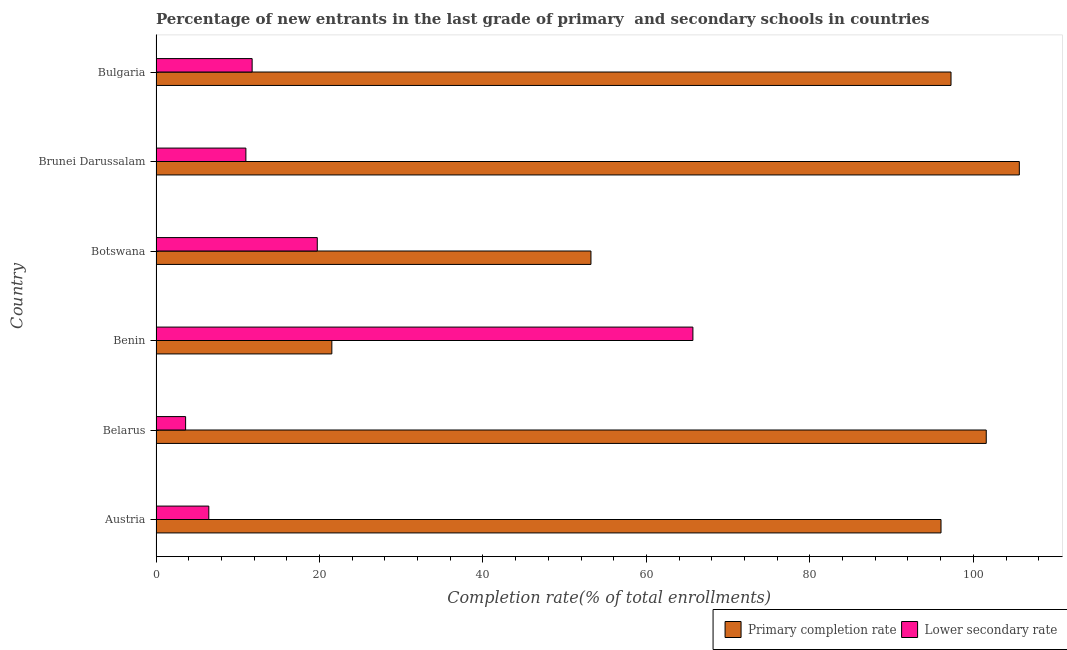Are the number of bars on each tick of the Y-axis equal?
Ensure brevity in your answer.  Yes. How many bars are there on the 2nd tick from the top?
Provide a succinct answer. 2. How many bars are there on the 2nd tick from the bottom?
Your answer should be very brief. 2. What is the completion rate in primary schools in Botswana?
Provide a succinct answer. 53.21. Across all countries, what is the maximum completion rate in secondary schools?
Ensure brevity in your answer.  65.69. Across all countries, what is the minimum completion rate in primary schools?
Your answer should be very brief. 21.51. In which country was the completion rate in secondary schools maximum?
Your response must be concise. Benin. In which country was the completion rate in secondary schools minimum?
Give a very brief answer. Belarus. What is the total completion rate in primary schools in the graph?
Ensure brevity in your answer.  475.22. What is the difference between the completion rate in primary schools in Austria and that in Belarus?
Keep it short and to the point. -5.54. What is the difference between the completion rate in secondary schools in Bulgaria and the completion rate in primary schools in Austria?
Make the answer very short. -84.28. What is the average completion rate in secondary schools per country?
Your answer should be compact. 19.71. What is the difference between the completion rate in secondary schools and completion rate in primary schools in Brunei Darussalam?
Your answer should be very brief. -94.63. What is the ratio of the completion rate in primary schools in Belarus to that in Benin?
Keep it short and to the point. 4.72. What is the difference between the highest and the second highest completion rate in secondary schools?
Your answer should be compact. 45.96. What is the difference between the highest and the lowest completion rate in primary schools?
Make the answer very short. 84.11. In how many countries, is the completion rate in primary schools greater than the average completion rate in primary schools taken over all countries?
Provide a succinct answer. 4. Is the sum of the completion rate in secondary schools in Belarus and Benin greater than the maximum completion rate in primary schools across all countries?
Offer a terse response. No. What does the 2nd bar from the top in Benin represents?
Make the answer very short. Primary completion rate. What does the 2nd bar from the bottom in Brunei Darussalam represents?
Your answer should be very brief. Lower secondary rate. How many bars are there?
Offer a very short reply. 12. Are all the bars in the graph horizontal?
Give a very brief answer. Yes. How many countries are there in the graph?
Give a very brief answer. 6. Does the graph contain grids?
Give a very brief answer. No. Where does the legend appear in the graph?
Make the answer very short. Bottom right. How many legend labels are there?
Make the answer very short. 2. How are the legend labels stacked?
Give a very brief answer. Horizontal. What is the title of the graph?
Give a very brief answer. Percentage of new entrants in the last grade of primary  and secondary schools in countries. What is the label or title of the X-axis?
Provide a short and direct response. Completion rate(% of total enrollments). What is the Completion rate(% of total enrollments) in Primary completion rate in Austria?
Offer a very short reply. 96.04. What is the Completion rate(% of total enrollments) of Lower secondary rate in Austria?
Provide a succinct answer. 6.46. What is the Completion rate(% of total enrollments) of Primary completion rate in Belarus?
Give a very brief answer. 101.58. What is the Completion rate(% of total enrollments) of Lower secondary rate in Belarus?
Offer a very short reply. 3.62. What is the Completion rate(% of total enrollments) of Primary completion rate in Benin?
Ensure brevity in your answer.  21.51. What is the Completion rate(% of total enrollments) of Lower secondary rate in Benin?
Give a very brief answer. 65.69. What is the Completion rate(% of total enrollments) in Primary completion rate in Botswana?
Provide a short and direct response. 53.21. What is the Completion rate(% of total enrollments) of Lower secondary rate in Botswana?
Your answer should be compact. 19.73. What is the Completion rate(% of total enrollments) in Primary completion rate in Brunei Darussalam?
Offer a terse response. 105.62. What is the Completion rate(% of total enrollments) in Lower secondary rate in Brunei Darussalam?
Your response must be concise. 10.99. What is the Completion rate(% of total enrollments) in Primary completion rate in Bulgaria?
Make the answer very short. 97.26. What is the Completion rate(% of total enrollments) in Lower secondary rate in Bulgaria?
Your answer should be compact. 11.76. Across all countries, what is the maximum Completion rate(% of total enrollments) of Primary completion rate?
Give a very brief answer. 105.62. Across all countries, what is the maximum Completion rate(% of total enrollments) of Lower secondary rate?
Your response must be concise. 65.69. Across all countries, what is the minimum Completion rate(% of total enrollments) in Primary completion rate?
Provide a short and direct response. 21.51. Across all countries, what is the minimum Completion rate(% of total enrollments) in Lower secondary rate?
Give a very brief answer. 3.62. What is the total Completion rate(% of total enrollments) in Primary completion rate in the graph?
Offer a terse response. 475.22. What is the total Completion rate(% of total enrollments) of Lower secondary rate in the graph?
Offer a very short reply. 118.25. What is the difference between the Completion rate(% of total enrollments) of Primary completion rate in Austria and that in Belarus?
Offer a very short reply. -5.54. What is the difference between the Completion rate(% of total enrollments) of Lower secondary rate in Austria and that in Belarus?
Ensure brevity in your answer.  2.84. What is the difference between the Completion rate(% of total enrollments) of Primary completion rate in Austria and that in Benin?
Provide a short and direct response. 74.53. What is the difference between the Completion rate(% of total enrollments) in Lower secondary rate in Austria and that in Benin?
Offer a terse response. -59.23. What is the difference between the Completion rate(% of total enrollments) in Primary completion rate in Austria and that in Botswana?
Give a very brief answer. 42.83. What is the difference between the Completion rate(% of total enrollments) of Lower secondary rate in Austria and that in Botswana?
Offer a very short reply. -13.27. What is the difference between the Completion rate(% of total enrollments) of Primary completion rate in Austria and that in Brunei Darussalam?
Keep it short and to the point. -9.58. What is the difference between the Completion rate(% of total enrollments) of Lower secondary rate in Austria and that in Brunei Darussalam?
Ensure brevity in your answer.  -4.54. What is the difference between the Completion rate(% of total enrollments) of Primary completion rate in Austria and that in Bulgaria?
Make the answer very short. -1.22. What is the difference between the Completion rate(% of total enrollments) of Lower secondary rate in Austria and that in Bulgaria?
Your answer should be very brief. -5.3. What is the difference between the Completion rate(% of total enrollments) of Primary completion rate in Belarus and that in Benin?
Offer a terse response. 80.06. What is the difference between the Completion rate(% of total enrollments) of Lower secondary rate in Belarus and that in Benin?
Provide a succinct answer. -62.07. What is the difference between the Completion rate(% of total enrollments) of Primary completion rate in Belarus and that in Botswana?
Your answer should be very brief. 48.36. What is the difference between the Completion rate(% of total enrollments) of Lower secondary rate in Belarus and that in Botswana?
Provide a succinct answer. -16.11. What is the difference between the Completion rate(% of total enrollments) of Primary completion rate in Belarus and that in Brunei Darussalam?
Make the answer very short. -4.05. What is the difference between the Completion rate(% of total enrollments) of Lower secondary rate in Belarus and that in Brunei Darussalam?
Provide a succinct answer. -7.37. What is the difference between the Completion rate(% of total enrollments) in Primary completion rate in Belarus and that in Bulgaria?
Ensure brevity in your answer.  4.31. What is the difference between the Completion rate(% of total enrollments) in Lower secondary rate in Belarus and that in Bulgaria?
Offer a terse response. -8.14. What is the difference between the Completion rate(% of total enrollments) in Primary completion rate in Benin and that in Botswana?
Give a very brief answer. -31.7. What is the difference between the Completion rate(% of total enrollments) in Lower secondary rate in Benin and that in Botswana?
Your response must be concise. 45.96. What is the difference between the Completion rate(% of total enrollments) of Primary completion rate in Benin and that in Brunei Darussalam?
Your response must be concise. -84.11. What is the difference between the Completion rate(% of total enrollments) in Lower secondary rate in Benin and that in Brunei Darussalam?
Give a very brief answer. 54.69. What is the difference between the Completion rate(% of total enrollments) of Primary completion rate in Benin and that in Bulgaria?
Offer a very short reply. -75.75. What is the difference between the Completion rate(% of total enrollments) of Lower secondary rate in Benin and that in Bulgaria?
Offer a very short reply. 53.93. What is the difference between the Completion rate(% of total enrollments) in Primary completion rate in Botswana and that in Brunei Darussalam?
Provide a succinct answer. -52.41. What is the difference between the Completion rate(% of total enrollments) in Lower secondary rate in Botswana and that in Brunei Darussalam?
Offer a terse response. 8.74. What is the difference between the Completion rate(% of total enrollments) in Primary completion rate in Botswana and that in Bulgaria?
Offer a terse response. -44.05. What is the difference between the Completion rate(% of total enrollments) of Lower secondary rate in Botswana and that in Bulgaria?
Provide a succinct answer. 7.97. What is the difference between the Completion rate(% of total enrollments) in Primary completion rate in Brunei Darussalam and that in Bulgaria?
Make the answer very short. 8.36. What is the difference between the Completion rate(% of total enrollments) of Lower secondary rate in Brunei Darussalam and that in Bulgaria?
Give a very brief answer. -0.77. What is the difference between the Completion rate(% of total enrollments) of Primary completion rate in Austria and the Completion rate(% of total enrollments) of Lower secondary rate in Belarus?
Provide a short and direct response. 92.42. What is the difference between the Completion rate(% of total enrollments) of Primary completion rate in Austria and the Completion rate(% of total enrollments) of Lower secondary rate in Benin?
Provide a short and direct response. 30.35. What is the difference between the Completion rate(% of total enrollments) in Primary completion rate in Austria and the Completion rate(% of total enrollments) in Lower secondary rate in Botswana?
Ensure brevity in your answer.  76.31. What is the difference between the Completion rate(% of total enrollments) of Primary completion rate in Austria and the Completion rate(% of total enrollments) of Lower secondary rate in Brunei Darussalam?
Ensure brevity in your answer.  85.05. What is the difference between the Completion rate(% of total enrollments) of Primary completion rate in Austria and the Completion rate(% of total enrollments) of Lower secondary rate in Bulgaria?
Your response must be concise. 84.28. What is the difference between the Completion rate(% of total enrollments) of Primary completion rate in Belarus and the Completion rate(% of total enrollments) of Lower secondary rate in Benin?
Provide a short and direct response. 35.89. What is the difference between the Completion rate(% of total enrollments) of Primary completion rate in Belarus and the Completion rate(% of total enrollments) of Lower secondary rate in Botswana?
Your answer should be compact. 81.85. What is the difference between the Completion rate(% of total enrollments) in Primary completion rate in Belarus and the Completion rate(% of total enrollments) in Lower secondary rate in Brunei Darussalam?
Provide a short and direct response. 90.58. What is the difference between the Completion rate(% of total enrollments) in Primary completion rate in Belarus and the Completion rate(% of total enrollments) in Lower secondary rate in Bulgaria?
Ensure brevity in your answer.  89.82. What is the difference between the Completion rate(% of total enrollments) in Primary completion rate in Benin and the Completion rate(% of total enrollments) in Lower secondary rate in Botswana?
Provide a short and direct response. 1.78. What is the difference between the Completion rate(% of total enrollments) in Primary completion rate in Benin and the Completion rate(% of total enrollments) in Lower secondary rate in Brunei Darussalam?
Offer a terse response. 10.52. What is the difference between the Completion rate(% of total enrollments) in Primary completion rate in Benin and the Completion rate(% of total enrollments) in Lower secondary rate in Bulgaria?
Ensure brevity in your answer.  9.75. What is the difference between the Completion rate(% of total enrollments) in Primary completion rate in Botswana and the Completion rate(% of total enrollments) in Lower secondary rate in Brunei Darussalam?
Provide a succinct answer. 42.22. What is the difference between the Completion rate(% of total enrollments) of Primary completion rate in Botswana and the Completion rate(% of total enrollments) of Lower secondary rate in Bulgaria?
Your answer should be very brief. 41.45. What is the difference between the Completion rate(% of total enrollments) in Primary completion rate in Brunei Darussalam and the Completion rate(% of total enrollments) in Lower secondary rate in Bulgaria?
Give a very brief answer. 93.86. What is the average Completion rate(% of total enrollments) of Primary completion rate per country?
Provide a short and direct response. 79.2. What is the average Completion rate(% of total enrollments) of Lower secondary rate per country?
Your response must be concise. 19.71. What is the difference between the Completion rate(% of total enrollments) of Primary completion rate and Completion rate(% of total enrollments) of Lower secondary rate in Austria?
Keep it short and to the point. 89.58. What is the difference between the Completion rate(% of total enrollments) in Primary completion rate and Completion rate(% of total enrollments) in Lower secondary rate in Belarus?
Give a very brief answer. 97.95. What is the difference between the Completion rate(% of total enrollments) of Primary completion rate and Completion rate(% of total enrollments) of Lower secondary rate in Benin?
Offer a very short reply. -44.17. What is the difference between the Completion rate(% of total enrollments) of Primary completion rate and Completion rate(% of total enrollments) of Lower secondary rate in Botswana?
Make the answer very short. 33.48. What is the difference between the Completion rate(% of total enrollments) of Primary completion rate and Completion rate(% of total enrollments) of Lower secondary rate in Brunei Darussalam?
Offer a very short reply. 94.63. What is the difference between the Completion rate(% of total enrollments) of Primary completion rate and Completion rate(% of total enrollments) of Lower secondary rate in Bulgaria?
Keep it short and to the point. 85.5. What is the ratio of the Completion rate(% of total enrollments) in Primary completion rate in Austria to that in Belarus?
Give a very brief answer. 0.95. What is the ratio of the Completion rate(% of total enrollments) in Lower secondary rate in Austria to that in Belarus?
Your answer should be compact. 1.78. What is the ratio of the Completion rate(% of total enrollments) in Primary completion rate in Austria to that in Benin?
Ensure brevity in your answer.  4.46. What is the ratio of the Completion rate(% of total enrollments) in Lower secondary rate in Austria to that in Benin?
Offer a terse response. 0.1. What is the ratio of the Completion rate(% of total enrollments) of Primary completion rate in Austria to that in Botswana?
Provide a short and direct response. 1.8. What is the ratio of the Completion rate(% of total enrollments) in Lower secondary rate in Austria to that in Botswana?
Your answer should be compact. 0.33. What is the ratio of the Completion rate(% of total enrollments) in Primary completion rate in Austria to that in Brunei Darussalam?
Your answer should be very brief. 0.91. What is the ratio of the Completion rate(% of total enrollments) of Lower secondary rate in Austria to that in Brunei Darussalam?
Your answer should be very brief. 0.59. What is the ratio of the Completion rate(% of total enrollments) in Primary completion rate in Austria to that in Bulgaria?
Give a very brief answer. 0.99. What is the ratio of the Completion rate(% of total enrollments) of Lower secondary rate in Austria to that in Bulgaria?
Your answer should be compact. 0.55. What is the ratio of the Completion rate(% of total enrollments) in Primary completion rate in Belarus to that in Benin?
Offer a terse response. 4.72. What is the ratio of the Completion rate(% of total enrollments) in Lower secondary rate in Belarus to that in Benin?
Your answer should be very brief. 0.06. What is the ratio of the Completion rate(% of total enrollments) of Primary completion rate in Belarus to that in Botswana?
Your answer should be compact. 1.91. What is the ratio of the Completion rate(% of total enrollments) of Lower secondary rate in Belarus to that in Botswana?
Your answer should be compact. 0.18. What is the ratio of the Completion rate(% of total enrollments) of Primary completion rate in Belarus to that in Brunei Darussalam?
Your answer should be very brief. 0.96. What is the ratio of the Completion rate(% of total enrollments) in Lower secondary rate in Belarus to that in Brunei Darussalam?
Your response must be concise. 0.33. What is the ratio of the Completion rate(% of total enrollments) in Primary completion rate in Belarus to that in Bulgaria?
Provide a succinct answer. 1.04. What is the ratio of the Completion rate(% of total enrollments) in Lower secondary rate in Belarus to that in Bulgaria?
Keep it short and to the point. 0.31. What is the ratio of the Completion rate(% of total enrollments) of Primary completion rate in Benin to that in Botswana?
Ensure brevity in your answer.  0.4. What is the ratio of the Completion rate(% of total enrollments) in Lower secondary rate in Benin to that in Botswana?
Offer a very short reply. 3.33. What is the ratio of the Completion rate(% of total enrollments) of Primary completion rate in Benin to that in Brunei Darussalam?
Ensure brevity in your answer.  0.2. What is the ratio of the Completion rate(% of total enrollments) in Lower secondary rate in Benin to that in Brunei Darussalam?
Offer a terse response. 5.97. What is the ratio of the Completion rate(% of total enrollments) of Primary completion rate in Benin to that in Bulgaria?
Provide a short and direct response. 0.22. What is the ratio of the Completion rate(% of total enrollments) of Lower secondary rate in Benin to that in Bulgaria?
Make the answer very short. 5.59. What is the ratio of the Completion rate(% of total enrollments) in Primary completion rate in Botswana to that in Brunei Darussalam?
Give a very brief answer. 0.5. What is the ratio of the Completion rate(% of total enrollments) of Lower secondary rate in Botswana to that in Brunei Darussalam?
Offer a terse response. 1.79. What is the ratio of the Completion rate(% of total enrollments) of Primary completion rate in Botswana to that in Bulgaria?
Your answer should be compact. 0.55. What is the ratio of the Completion rate(% of total enrollments) in Lower secondary rate in Botswana to that in Bulgaria?
Provide a short and direct response. 1.68. What is the ratio of the Completion rate(% of total enrollments) of Primary completion rate in Brunei Darussalam to that in Bulgaria?
Ensure brevity in your answer.  1.09. What is the ratio of the Completion rate(% of total enrollments) in Lower secondary rate in Brunei Darussalam to that in Bulgaria?
Provide a succinct answer. 0.93. What is the difference between the highest and the second highest Completion rate(% of total enrollments) in Primary completion rate?
Ensure brevity in your answer.  4.05. What is the difference between the highest and the second highest Completion rate(% of total enrollments) in Lower secondary rate?
Your response must be concise. 45.96. What is the difference between the highest and the lowest Completion rate(% of total enrollments) in Primary completion rate?
Provide a succinct answer. 84.11. What is the difference between the highest and the lowest Completion rate(% of total enrollments) in Lower secondary rate?
Offer a terse response. 62.07. 